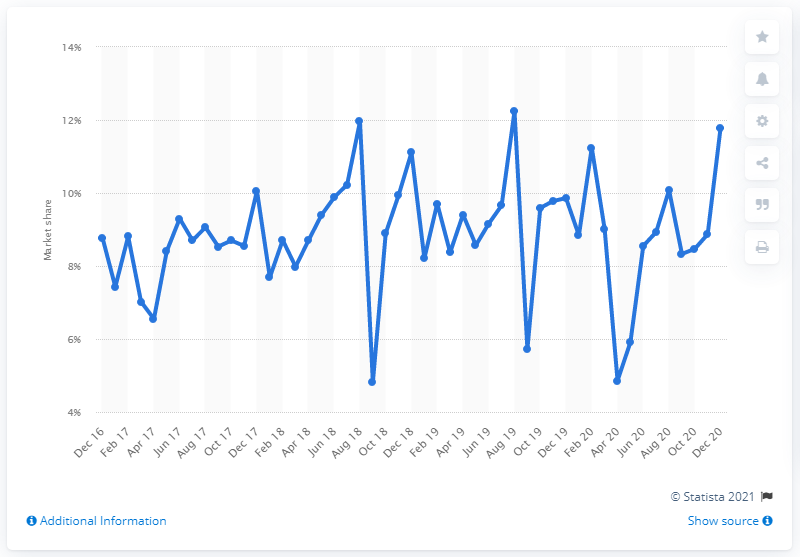Mention a couple of crucial points in this snapshot. In December 2020, Volkswagen's market share in the UK was 11.78%. 